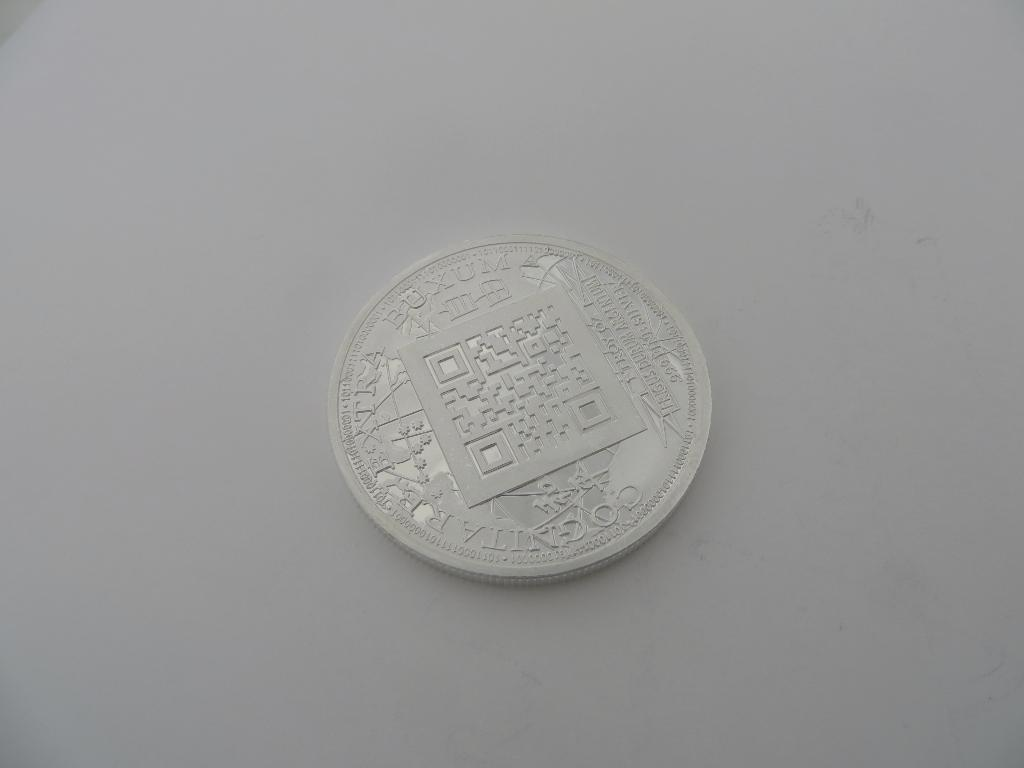Provide a one-sentence caption for the provided image. Cognitarextra Buxum is etched onto the face of this coin. 